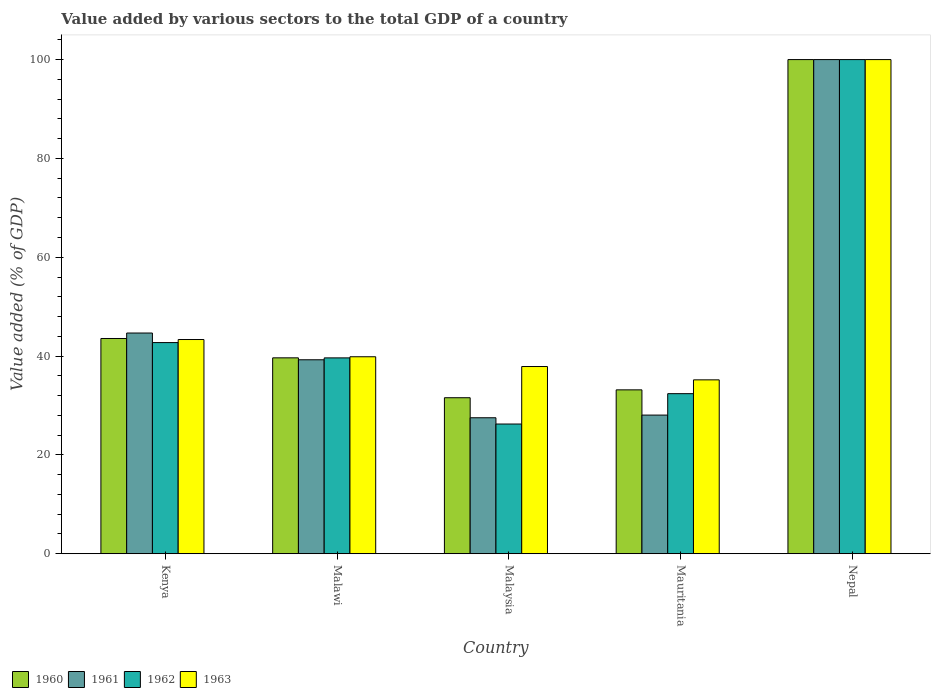How many different coloured bars are there?
Make the answer very short. 4. How many groups of bars are there?
Offer a very short reply. 5. Are the number of bars per tick equal to the number of legend labels?
Offer a terse response. Yes. How many bars are there on the 4th tick from the left?
Provide a short and direct response. 4. How many bars are there on the 4th tick from the right?
Make the answer very short. 4. What is the label of the 5th group of bars from the left?
Offer a terse response. Nepal. In how many cases, is the number of bars for a given country not equal to the number of legend labels?
Keep it short and to the point. 0. What is the value added by various sectors to the total GDP in 1960 in Malaysia?
Provide a short and direct response. 31.57. Across all countries, what is the maximum value added by various sectors to the total GDP in 1960?
Ensure brevity in your answer.  100. Across all countries, what is the minimum value added by various sectors to the total GDP in 1961?
Keep it short and to the point. 27.52. In which country was the value added by various sectors to the total GDP in 1963 maximum?
Your answer should be compact. Nepal. In which country was the value added by various sectors to the total GDP in 1961 minimum?
Your answer should be very brief. Malaysia. What is the total value added by various sectors to the total GDP in 1961 in the graph?
Give a very brief answer. 239.5. What is the difference between the value added by various sectors to the total GDP in 1963 in Kenya and that in Nepal?
Provide a succinct answer. -56.65. What is the difference between the value added by various sectors to the total GDP in 1960 in Malawi and the value added by various sectors to the total GDP in 1961 in Mauritania?
Your answer should be compact. 11.59. What is the average value added by various sectors to the total GDP in 1962 per country?
Offer a very short reply. 48.2. What is the difference between the value added by various sectors to the total GDP of/in 1961 and value added by various sectors to the total GDP of/in 1963 in Nepal?
Offer a very short reply. 0. In how many countries, is the value added by various sectors to the total GDP in 1962 greater than 100 %?
Make the answer very short. 0. What is the ratio of the value added by various sectors to the total GDP in 1960 in Malawi to that in Malaysia?
Make the answer very short. 1.26. What is the difference between the highest and the second highest value added by various sectors to the total GDP in 1961?
Ensure brevity in your answer.  55.33. What is the difference between the highest and the lowest value added by various sectors to the total GDP in 1961?
Offer a terse response. 72.48. In how many countries, is the value added by various sectors to the total GDP in 1963 greater than the average value added by various sectors to the total GDP in 1963 taken over all countries?
Keep it short and to the point. 1. Is the sum of the value added by various sectors to the total GDP in 1960 in Malawi and Nepal greater than the maximum value added by various sectors to the total GDP in 1961 across all countries?
Your response must be concise. Yes. Is it the case that in every country, the sum of the value added by various sectors to the total GDP in 1963 and value added by various sectors to the total GDP in 1961 is greater than the sum of value added by various sectors to the total GDP in 1962 and value added by various sectors to the total GDP in 1960?
Your response must be concise. No. What does the 3rd bar from the left in Kenya represents?
Keep it short and to the point. 1962. What does the 3rd bar from the right in Nepal represents?
Provide a short and direct response. 1961. Is it the case that in every country, the sum of the value added by various sectors to the total GDP in 1963 and value added by various sectors to the total GDP in 1960 is greater than the value added by various sectors to the total GDP in 1962?
Your answer should be very brief. Yes. How many bars are there?
Give a very brief answer. 20. How many countries are there in the graph?
Offer a very short reply. 5. Are the values on the major ticks of Y-axis written in scientific E-notation?
Your answer should be compact. No. How are the legend labels stacked?
Your answer should be very brief. Horizontal. What is the title of the graph?
Your answer should be compact. Value added by various sectors to the total GDP of a country. What is the label or title of the X-axis?
Make the answer very short. Country. What is the label or title of the Y-axis?
Provide a short and direct response. Value added (% of GDP). What is the Value added (% of GDP) in 1960 in Kenya?
Your answer should be very brief. 43.56. What is the Value added (% of GDP) in 1961 in Kenya?
Your response must be concise. 44.67. What is the Value added (% of GDP) in 1962 in Kenya?
Ensure brevity in your answer.  42.73. What is the Value added (% of GDP) in 1963 in Kenya?
Provide a succinct answer. 43.35. What is the Value added (% of GDP) in 1960 in Malawi?
Your answer should be very brief. 39.64. What is the Value added (% of GDP) in 1961 in Malawi?
Offer a very short reply. 39.25. What is the Value added (% of GDP) of 1962 in Malawi?
Offer a very short reply. 39.64. What is the Value added (% of GDP) in 1963 in Malawi?
Your answer should be very brief. 39.86. What is the Value added (% of GDP) in 1960 in Malaysia?
Your answer should be very brief. 31.57. What is the Value added (% of GDP) in 1961 in Malaysia?
Your response must be concise. 27.52. What is the Value added (% of GDP) of 1962 in Malaysia?
Make the answer very short. 26.25. What is the Value added (% of GDP) in 1963 in Malaysia?
Your answer should be compact. 37.89. What is the Value added (% of GDP) of 1960 in Mauritania?
Keep it short and to the point. 33.17. What is the Value added (% of GDP) in 1961 in Mauritania?
Offer a terse response. 28.06. What is the Value added (% of GDP) in 1962 in Mauritania?
Your response must be concise. 32.4. What is the Value added (% of GDP) of 1963 in Mauritania?
Ensure brevity in your answer.  35.19. What is the Value added (% of GDP) in 1961 in Nepal?
Ensure brevity in your answer.  100. What is the Value added (% of GDP) of 1962 in Nepal?
Make the answer very short. 100. What is the Value added (% of GDP) of 1963 in Nepal?
Give a very brief answer. 100. Across all countries, what is the maximum Value added (% of GDP) of 1960?
Offer a terse response. 100. Across all countries, what is the maximum Value added (% of GDP) in 1962?
Your response must be concise. 100. Across all countries, what is the minimum Value added (% of GDP) in 1960?
Your answer should be very brief. 31.57. Across all countries, what is the minimum Value added (% of GDP) of 1961?
Keep it short and to the point. 27.52. Across all countries, what is the minimum Value added (% of GDP) of 1962?
Ensure brevity in your answer.  26.25. Across all countries, what is the minimum Value added (% of GDP) of 1963?
Your answer should be compact. 35.19. What is the total Value added (% of GDP) in 1960 in the graph?
Your response must be concise. 247.94. What is the total Value added (% of GDP) of 1961 in the graph?
Give a very brief answer. 239.5. What is the total Value added (% of GDP) in 1962 in the graph?
Provide a short and direct response. 241.01. What is the total Value added (% of GDP) of 1963 in the graph?
Offer a terse response. 256.29. What is the difference between the Value added (% of GDP) of 1960 in Kenya and that in Malawi?
Give a very brief answer. 3.92. What is the difference between the Value added (% of GDP) in 1961 in Kenya and that in Malawi?
Your response must be concise. 5.41. What is the difference between the Value added (% of GDP) of 1962 in Kenya and that in Malawi?
Your answer should be compact. 3.1. What is the difference between the Value added (% of GDP) of 1963 in Kenya and that in Malawi?
Offer a terse response. 3.49. What is the difference between the Value added (% of GDP) of 1960 in Kenya and that in Malaysia?
Offer a terse response. 11.99. What is the difference between the Value added (% of GDP) in 1961 in Kenya and that in Malaysia?
Your answer should be very brief. 17.15. What is the difference between the Value added (% of GDP) of 1962 in Kenya and that in Malaysia?
Your answer should be very brief. 16.48. What is the difference between the Value added (% of GDP) in 1963 in Kenya and that in Malaysia?
Provide a short and direct response. 5.46. What is the difference between the Value added (% of GDP) in 1960 in Kenya and that in Mauritania?
Provide a short and direct response. 10.39. What is the difference between the Value added (% of GDP) in 1961 in Kenya and that in Mauritania?
Provide a short and direct response. 16.61. What is the difference between the Value added (% of GDP) of 1962 in Kenya and that in Mauritania?
Your answer should be very brief. 10.34. What is the difference between the Value added (% of GDP) in 1963 in Kenya and that in Mauritania?
Offer a terse response. 8.16. What is the difference between the Value added (% of GDP) in 1960 in Kenya and that in Nepal?
Ensure brevity in your answer.  -56.44. What is the difference between the Value added (% of GDP) in 1961 in Kenya and that in Nepal?
Your response must be concise. -55.33. What is the difference between the Value added (% of GDP) in 1962 in Kenya and that in Nepal?
Make the answer very short. -57.27. What is the difference between the Value added (% of GDP) of 1963 in Kenya and that in Nepal?
Your response must be concise. -56.65. What is the difference between the Value added (% of GDP) of 1960 in Malawi and that in Malaysia?
Keep it short and to the point. 8.07. What is the difference between the Value added (% of GDP) of 1961 in Malawi and that in Malaysia?
Your answer should be compact. 11.73. What is the difference between the Value added (% of GDP) in 1962 in Malawi and that in Malaysia?
Offer a terse response. 13.39. What is the difference between the Value added (% of GDP) in 1963 in Malawi and that in Malaysia?
Keep it short and to the point. 1.98. What is the difference between the Value added (% of GDP) of 1960 in Malawi and that in Mauritania?
Offer a very short reply. 6.48. What is the difference between the Value added (% of GDP) in 1961 in Malawi and that in Mauritania?
Offer a terse response. 11.2. What is the difference between the Value added (% of GDP) in 1962 in Malawi and that in Mauritania?
Make the answer very short. 7.24. What is the difference between the Value added (% of GDP) in 1963 in Malawi and that in Mauritania?
Your answer should be very brief. 4.67. What is the difference between the Value added (% of GDP) in 1960 in Malawi and that in Nepal?
Provide a succinct answer. -60.36. What is the difference between the Value added (% of GDP) of 1961 in Malawi and that in Nepal?
Your answer should be very brief. -60.75. What is the difference between the Value added (% of GDP) of 1962 in Malawi and that in Nepal?
Your answer should be very brief. -60.36. What is the difference between the Value added (% of GDP) in 1963 in Malawi and that in Nepal?
Offer a terse response. -60.14. What is the difference between the Value added (% of GDP) in 1960 in Malaysia and that in Mauritania?
Give a very brief answer. -1.59. What is the difference between the Value added (% of GDP) of 1961 in Malaysia and that in Mauritania?
Offer a terse response. -0.54. What is the difference between the Value added (% of GDP) in 1962 in Malaysia and that in Mauritania?
Keep it short and to the point. -6.15. What is the difference between the Value added (% of GDP) in 1963 in Malaysia and that in Mauritania?
Offer a very short reply. 2.7. What is the difference between the Value added (% of GDP) in 1960 in Malaysia and that in Nepal?
Your response must be concise. -68.43. What is the difference between the Value added (% of GDP) of 1961 in Malaysia and that in Nepal?
Offer a terse response. -72.48. What is the difference between the Value added (% of GDP) in 1962 in Malaysia and that in Nepal?
Offer a very short reply. -73.75. What is the difference between the Value added (% of GDP) in 1963 in Malaysia and that in Nepal?
Keep it short and to the point. -62.11. What is the difference between the Value added (% of GDP) of 1960 in Mauritania and that in Nepal?
Provide a short and direct response. -66.83. What is the difference between the Value added (% of GDP) in 1961 in Mauritania and that in Nepal?
Offer a very short reply. -71.94. What is the difference between the Value added (% of GDP) of 1962 in Mauritania and that in Nepal?
Your answer should be very brief. -67.6. What is the difference between the Value added (% of GDP) in 1963 in Mauritania and that in Nepal?
Provide a succinct answer. -64.81. What is the difference between the Value added (% of GDP) in 1960 in Kenya and the Value added (% of GDP) in 1961 in Malawi?
Your answer should be compact. 4.31. What is the difference between the Value added (% of GDP) of 1960 in Kenya and the Value added (% of GDP) of 1962 in Malawi?
Your answer should be compact. 3.92. What is the difference between the Value added (% of GDP) in 1960 in Kenya and the Value added (% of GDP) in 1963 in Malawi?
Offer a terse response. 3.7. What is the difference between the Value added (% of GDP) in 1961 in Kenya and the Value added (% of GDP) in 1962 in Malawi?
Provide a short and direct response. 5.03. What is the difference between the Value added (% of GDP) in 1961 in Kenya and the Value added (% of GDP) in 1963 in Malawi?
Your answer should be very brief. 4.8. What is the difference between the Value added (% of GDP) of 1962 in Kenya and the Value added (% of GDP) of 1963 in Malawi?
Offer a very short reply. 2.87. What is the difference between the Value added (% of GDP) in 1960 in Kenya and the Value added (% of GDP) in 1961 in Malaysia?
Make the answer very short. 16.04. What is the difference between the Value added (% of GDP) in 1960 in Kenya and the Value added (% of GDP) in 1962 in Malaysia?
Provide a short and direct response. 17.31. What is the difference between the Value added (% of GDP) in 1960 in Kenya and the Value added (% of GDP) in 1963 in Malaysia?
Your answer should be compact. 5.67. What is the difference between the Value added (% of GDP) of 1961 in Kenya and the Value added (% of GDP) of 1962 in Malaysia?
Your response must be concise. 18.42. What is the difference between the Value added (% of GDP) in 1961 in Kenya and the Value added (% of GDP) in 1963 in Malaysia?
Your answer should be compact. 6.78. What is the difference between the Value added (% of GDP) of 1962 in Kenya and the Value added (% of GDP) of 1963 in Malaysia?
Offer a very short reply. 4.84. What is the difference between the Value added (% of GDP) of 1960 in Kenya and the Value added (% of GDP) of 1961 in Mauritania?
Your answer should be very brief. 15.5. What is the difference between the Value added (% of GDP) in 1960 in Kenya and the Value added (% of GDP) in 1962 in Mauritania?
Give a very brief answer. 11.16. What is the difference between the Value added (% of GDP) of 1960 in Kenya and the Value added (% of GDP) of 1963 in Mauritania?
Your answer should be compact. 8.37. What is the difference between the Value added (% of GDP) in 1961 in Kenya and the Value added (% of GDP) in 1962 in Mauritania?
Your response must be concise. 12.27. What is the difference between the Value added (% of GDP) in 1961 in Kenya and the Value added (% of GDP) in 1963 in Mauritania?
Your answer should be compact. 9.48. What is the difference between the Value added (% of GDP) of 1962 in Kenya and the Value added (% of GDP) of 1963 in Mauritania?
Ensure brevity in your answer.  7.54. What is the difference between the Value added (% of GDP) in 1960 in Kenya and the Value added (% of GDP) in 1961 in Nepal?
Make the answer very short. -56.44. What is the difference between the Value added (% of GDP) of 1960 in Kenya and the Value added (% of GDP) of 1962 in Nepal?
Offer a terse response. -56.44. What is the difference between the Value added (% of GDP) in 1960 in Kenya and the Value added (% of GDP) in 1963 in Nepal?
Keep it short and to the point. -56.44. What is the difference between the Value added (% of GDP) of 1961 in Kenya and the Value added (% of GDP) of 1962 in Nepal?
Keep it short and to the point. -55.33. What is the difference between the Value added (% of GDP) of 1961 in Kenya and the Value added (% of GDP) of 1963 in Nepal?
Make the answer very short. -55.33. What is the difference between the Value added (% of GDP) in 1962 in Kenya and the Value added (% of GDP) in 1963 in Nepal?
Offer a terse response. -57.27. What is the difference between the Value added (% of GDP) in 1960 in Malawi and the Value added (% of GDP) in 1961 in Malaysia?
Offer a terse response. 12.13. What is the difference between the Value added (% of GDP) in 1960 in Malawi and the Value added (% of GDP) in 1962 in Malaysia?
Provide a succinct answer. 13.39. What is the difference between the Value added (% of GDP) in 1960 in Malawi and the Value added (% of GDP) in 1963 in Malaysia?
Keep it short and to the point. 1.76. What is the difference between the Value added (% of GDP) of 1961 in Malawi and the Value added (% of GDP) of 1962 in Malaysia?
Make the answer very short. 13. What is the difference between the Value added (% of GDP) in 1961 in Malawi and the Value added (% of GDP) in 1963 in Malaysia?
Keep it short and to the point. 1.37. What is the difference between the Value added (% of GDP) of 1962 in Malawi and the Value added (% of GDP) of 1963 in Malaysia?
Give a very brief answer. 1.75. What is the difference between the Value added (% of GDP) in 1960 in Malawi and the Value added (% of GDP) in 1961 in Mauritania?
Provide a succinct answer. 11.59. What is the difference between the Value added (% of GDP) of 1960 in Malawi and the Value added (% of GDP) of 1962 in Mauritania?
Offer a very short reply. 7.25. What is the difference between the Value added (% of GDP) in 1960 in Malawi and the Value added (% of GDP) in 1963 in Mauritania?
Keep it short and to the point. 4.45. What is the difference between the Value added (% of GDP) of 1961 in Malawi and the Value added (% of GDP) of 1962 in Mauritania?
Keep it short and to the point. 6.86. What is the difference between the Value added (% of GDP) in 1961 in Malawi and the Value added (% of GDP) in 1963 in Mauritania?
Offer a very short reply. 4.06. What is the difference between the Value added (% of GDP) in 1962 in Malawi and the Value added (% of GDP) in 1963 in Mauritania?
Make the answer very short. 4.45. What is the difference between the Value added (% of GDP) in 1960 in Malawi and the Value added (% of GDP) in 1961 in Nepal?
Make the answer very short. -60.36. What is the difference between the Value added (% of GDP) in 1960 in Malawi and the Value added (% of GDP) in 1962 in Nepal?
Provide a short and direct response. -60.36. What is the difference between the Value added (% of GDP) of 1960 in Malawi and the Value added (% of GDP) of 1963 in Nepal?
Provide a succinct answer. -60.36. What is the difference between the Value added (% of GDP) of 1961 in Malawi and the Value added (% of GDP) of 1962 in Nepal?
Make the answer very short. -60.75. What is the difference between the Value added (% of GDP) in 1961 in Malawi and the Value added (% of GDP) in 1963 in Nepal?
Your answer should be very brief. -60.75. What is the difference between the Value added (% of GDP) of 1962 in Malawi and the Value added (% of GDP) of 1963 in Nepal?
Ensure brevity in your answer.  -60.36. What is the difference between the Value added (% of GDP) of 1960 in Malaysia and the Value added (% of GDP) of 1961 in Mauritania?
Provide a short and direct response. 3.51. What is the difference between the Value added (% of GDP) in 1960 in Malaysia and the Value added (% of GDP) in 1962 in Mauritania?
Make the answer very short. -0.82. What is the difference between the Value added (% of GDP) in 1960 in Malaysia and the Value added (% of GDP) in 1963 in Mauritania?
Make the answer very short. -3.62. What is the difference between the Value added (% of GDP) of 1961 in Malaysia and the Value added (% of GDP) of 1962 in Mauritania?
Ensure brevity in your answer.  -4.88. What is the difference between the Value added (% of GDP) of 1961 in Malaysia and the Value added (% of GDP) of 1963 in Mauritania?
Your answer should be compact. -7.67. What is the difference between the Value added (% of GDP) of 1962 in Malaysia and the Value added (% of GDP) of 1963 in Mauritania?
Provide a short and direct response. -8.94. What is the difference between the Value added (% of GDP) in 1960 in Malaysia and the Value added (% of GDP) in 1961 in Nepal?
Provide a succinct answer. -68.43. What is the difference between the Value added (% of GDP) in 1960 in Malaysia and the Value added (% of GDP) in 1962 in Nepal?
Your answer should be compact. -68.43. What is the difference between the Value added (% of GDP) in 1960 in Malaysia and the Value added (% of GDP) in 1963 in Nepal?
Your answer should be very brief. -68.43. What is the difference between the Value added (% of GDP) of 1961 in Malaysia and the Value added (% of GDP) of 1962 in Nepal?
Offer a very short reply. -72.48. What is the difference between the Value added (% of GDP) of 1961 in Malaysia and the Value added (% of GDP) of 1963 in Nepal?
Offer a terse response. -72.48. What is the difference between the Value added (% of GDP) in 1962 in Malaysia and the Value added (% of GDP) in 1963 in Nepal?
Ensure brevity in your answer.  -73.75. What is the difference between the Value added (% of GDP) in 1960 in Mauritania and the Value added (% of GDP) in 1961 in Nepal?
Make the answer very short. -66.83. What is the difference between the Value added (% of GDP) in 1960 in Mauritania and the Value added (% of GDP) in 1962 in Nepal?
Provide a succinct answer. -66.83. What is the difference between the Value added (% of GDP) of 1960 in Mauritania and the Value added (% of GDP) of 1963 in Nepal?
Provide a succinct answer. -66.83. What is the difference between the Value added (% of GDP) in 1961 in Mauritania and the Value added (% of GDP) in 1962 in Nepal?
Provide a short and direct response. -71.94. What is the difference between the Value added (% of GDP) in 1961 in Mauritania and the Value added (% of GDP) in 1963 in Nepal?
Provide a succinct answer. -71.94. What is the difference between the Value added (% of GDP) in 1962 in Mauritania and the Value added (% of GDP) in 1963 in Nepal?
Offer a very short reply. -67.6. What is the average Value added (% of GDP) of 1960 per country?
Provide a short and direct response. 49.59. What is the average Value added (% of GDP) of 1961 per country?
Give a very brief answer. 47.9. What is the average Value added (% of GDP) in 1962 per country?
Offer a terse response. 48.2. What is the average Value added (% of GDP) in 1963 per country?
Make the answer very short. 51.26. What is the difference between the Value added (% of GDP) in 1960 and Value added (% of GDP) in 1961 in Kenya?
Provide a succinct answer. -1.11. What is the difference between the Value added (% of GDP) in 1960 and Value added (% of GDP) in 1962 in Kenya?
Make the answer very short. 0.83. What is the difference between the Value added (% of GDP) of 1960 and Value added (% of GDP) of 1963 in Kenya?
Your answer should be very brief. 0.21. What is the difference between the Value added (% of GDP) of 1961 and Value added (% of GDP) of 1962 in Kenya?
Your answer should be compact. 1.94. What is the difference between the Value added (% of GDP) in 1961 and Value added (% of GDP) in 1963 in Kenya?
Provide a succinct answer. 1.32. What is the difference between the Value added (% of GDP) in 1962 and Value added (% of GDP) in 1963 in Kenya?
Your response must be concise. -0.62. What is the difference between the Value added (% of GDP) in 1960 and Value added (% of GDP) in 1961 in Malawi?
Provide a short and direct response. 0.39. What is the difference between the Value added (% of GDP) of 1960 and Value added (% of GDP) of 1962 in Malawi?
Your response must be concise. 0.01. What is the difference between the Value added (% of GDP) in 1960 and Value added (% of GDP) in 1963 in Malawi?
Ensure brevity in your answer.  -0.22. What is the difference between the Value added (% of GDP) in 1961 and Value added (% of GDP) in 1962 in Malawi?
Offer a very short reply. -0.38. What is the difference between the Value added (% of GDP) in 1961 and Value added (% of GDP) in 1963 in Malawi?
Your answer should be very brief. -0.61. What is the difference between the Value added (% of GDP) of 1962 and Value added (% of GDP) of 1963 in Malawi?
Provide a succinct answer. -0.23. What is the difference between the Value added (% of GDP) in 1960 and Value added (% of GDP) in 1961 in Malaysia?
Give a very brief answer. 4.05. What is the difference between the Value added (% of GDP) in 1960 and Value added (% of GDP) in 1962 in Malaysia?
Give a very brief answer. 5.32. What is the difference between the Value added (% of GDP) of 1960 and Value added (% of GDP) of 1963 in Malaysia?
Provide a short and direct response. -6.31. What is the difference between the Value added (% of GDP) in 1961 and Value added (% of GDP) in 1962 in Malaysia?
Keep it short and to the point. 1.27. What is the difference between the Value added (% of GDP) in 1961 and Value added (% of GDP) in 1963 in Malaysia?
Provide a succinct answer. -10.37. What is the difference between the Value added (% of GDP) of 1962 and Value added (% of GDP) of 1963 in Malaysia?
Make the answer very short. -11.64. What is the difference between the Value added (% of GDP) of 1960 and Value added (% of GDP) of 1961 in Mauritania?
Provide a short and direct response. 5.11. What is the difference between the Value added (% of GDP) of 1960 and Value added (% of GDP) of 1962 in Mauritania?
Your response must be concise. 0.77. What is the difference between the Value added (% of GDP) of 1960 and Value added (% of GDP) of 1963 in Mauritania?
Offer a very short reply. -2.02. What is the difference between the Value added (% of GDP) of 1961 and Value added (% of GDP) of 1962 in Mauritania?
Offer a terse response. -4.34. What is the difference between the Value added (% of GDP) in 1961 and Value added (% of GDP) in 1963 in Mauritania?
Provide a short and direct response. -7.13. What is the difference between the Value added (% of GDP) in 1962 and Value added (% of GDP) in 1963 in Mauritania?
Ensure brevity in your answer.  -2.79. What is the ratio of the Value added (% of GDP) of 1960 in Kenya to that in Malawi?
Keep it short and to the point. 1.1. What is the ratio of the Value added (% of GDP) in 1961 in Kenya to that in Malawi?
Ensure brevity in your answer.  1.14. What is the ratio of the Value added (% of GDP) of 1962 in Kenya to that in Malawi?
Make the answer very short. 1.08. What is the ratio of the Value added (% of GDP) in 1963 in Kenya to that in Malawi?
Offer a very short reply. 1.09. What is the ratio of the Value added (% of GDP) in 1960 in Kenya to that in Malaysia?
Provide a succinct answer. 1.38. What is the ratio of the Value added (% of GDP) in 1961 in Kenya to that in Malaysia?
Ensure brevity in your answer.  1.62. What is the ratio of the Value added (% of GDP) in 1962 in Kenya to that in Malaysia?
Keep it short and to the point. 1.63. What is the ratio of the Value added (% of GDP) of 1963 in Kenya to that in Malaysia?
Your answer should be very brief. 1.14. What is the ratio of the Value added (% of GDP) of 1960 in Kenya to that in Mauritania?
Offer a very short reply. 1.31. What is the ratio of the Value added (% of GDP) in 1961 in Kenya to that in Mauritania?
Your response must be concise. 1.59. What is the ratio of the Value added (% of GDP) of 1962 in Kenya to that in Mauritania?
Your answer should be compact. 1.32. What is the ratio of the Value added (% of GDP) of 1963 in Kenya to that in Mauritania?
Make the answer very short. 1.23. What is the ratio of the Value added (% of GDP) in 1960 in Kenya to that in Nepal?
Make the answer very short. 0.44. What is the ratio of the Value added (% of GDP) of 1961 in Kenya to that in Nepal?
Your answer should be compact. 0.45. What is the ratio of the Value added (% of GDP) of 1962 in Kenya to that in Nepal?
Offer a very short reply. 0.43. What is the ratio of the Value added (% of GDP) of 1963 in Kenya to that in Nepal?
Keep it short and to the point. 0.43. What is the ratio of the Value added (% of GDP) of 1960 in Malawi to that in Malaysia?
Make the answer very short. 1.26. What is the ratio of the Value added (% of GDP) in 1961 in Malawi to that in Malaysia?
Your answer should be very brief. 1.43. What is the ratio of the Value added (% of GDP) of 1962 in Malawi to that in Malaysia?
Provide a succinct answer. 1.51. What is the ratio of the Value added (% of GDP) in 1963 in Malawi to that in Malaysia?
Keep it short and to the point. 1.05. What is the ratio of the Value added (% of GDP) of 1960 in Malawi to that in Mauritania?
Offer a very short reply. 1.2. What is the ratio of the Value added (% of GDP) in 1961 in Malawi to that in Mauritania?
Ensure brevity in your answer.  1.4. What is the ratio of the Value added (% of GDP) in 1962 in Malawi to that in Mauritania?
Provide a short and direct response. 1.22. What is the ratio of the Value added (% of GDP) of 1963 in Malawi to that in Mauritania?
Your answer should be very brief. 1.13. What is the ratio of the Value added (% of GDP) in 1960 in Malawi to that in Nepal?
Keep it short and to the point. 0.4. What is the ratio of the Value added (% of GDP) in 1961 in Malawi to that in Nepal?
Your response must be concise. 0.39. What is the ratio of the Value added (% of GDP) in 1962 in Malawi to that in Nepal?
Offer a terse response. 0.4. What is the ratio of the Value added (% of GDP) in 1963 in Malawi to that in Nepal?
Your answer should be compact. 0.4. What is the ratio of the Value added (% of GDP) of 1961 in Malaysia to that in Mauritania?
Ensure brevity in your answer.  0.98. What is the ratio of the Value added (% of GDP) of 1962 in Malaysia to that in Mauritania?
Give a very brief answer. 0.81. What is the ratio of the Value added (% of GDP) of 1963 in Malaysia to that in Mauritania?
Your response must be concise. 1.08. What is the ratio of the Value added (% of GDP) of 1960 in Malaysia to that in Nepal?
Your answer should be compact. 0.32. What is the ratio of the Value added (% of GDP) in 1961 in Malaysia to that in Nepal?
Offer a terse response. 0.28. What is the ratio of the Value added (% of GDP) of 1962 in Malaysia to that in Nepal?
Give a very brief answer. 0.26. What is the ratio of the Value added (% of GDP) of 1963 in Malaysia to that in Nepal?
Make the answer very short. 0.38. What is the ratio of the Value added (% of GDP) in 1960 in Mauritania to that in Nepal?
Your answer should be compact. 0.33. What is the ratio of the Value added (% of GDP) of 1961 in Mauritania to that in Nepal?
Ensure brevity in your answer.  0.28. What is the ratio of the Value added (% of GDP) of 1962 in Mauritania to that in Nepal?
Your response must be concise. 0.32. What is the ratio of the Value added (% of GDP) of 1963 in Mauritania to that in Nepal?
Provide a short and direct response. 0.35. What is the difference between the highest and the second highest Value added (% of GDP) in 1960?
Provide a short and direct response. 56.44. What is the difference between the highest and the second highest Value added (% of GDP) of 1961?
Ensure brevity in your answer.  55.33. What is the difference between the highest and the second highest Value added (% of GDP) of 1962?
Offer a terse response. 57.27. What is the difference between the highest and the second highest Value added (% of GDP) in 1963?
Offer a terse response. 56.65. What is the difference between the highest and the lowest Value added (% of GDP) of 1960?
Provide a succinct answer. 68.43. What is the difference between the highest and the lowest Value added (% of GDP) in 1961?
Ensure brevity in your answer.  72.48. What is the difference between the highest and the lowest Value added (% of GDP) of 1962?
Ensure brevity in your answer.  73.75. What is the difference between the highest and the lowest Value added (% of GDP) of 1963?
Make the answer very short. 64.81. 